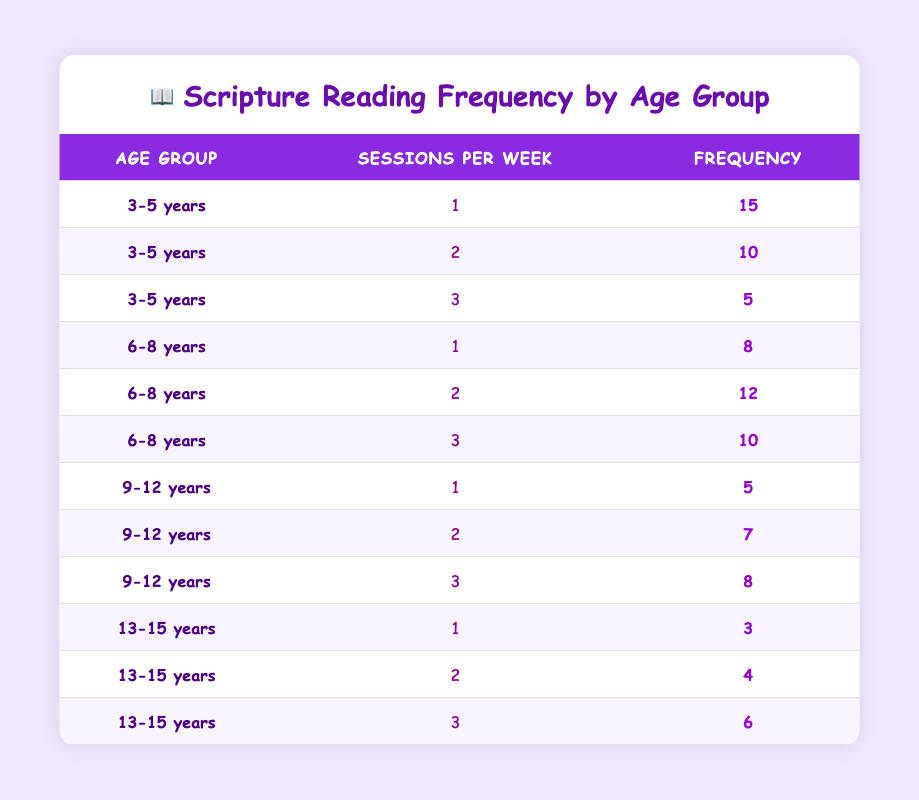What is the frequency of 3 sessions per week for the age group 3-5 years? In the table, under the age group 3-5 years, the frequency for 3 sessions per week is explicitly listed as 5. Therefore, this value can be directly retrieved from the table.
Answer: 5 How many children in the age group 6-8 years participate in one scripture reading session per week? According to the table, for the age group 6-8 years, the frequency for one session per week is recorded as 8. This can be found without further calculations.
Answer: 8 What is the total frequency of children reading scriptures 2 times a week across all age groups? To find this, I look at the table for the frequency of 2 sessions per week for each age group. For 3-5 years, it's 10, for 6-8 years it's 12, for 9-12 years it's 7, and for 13-15 years it's 4. Summing these gives: 10 + 12 + 7 + 4 = 33.
Answer: 33 Is it true that more children in the age group 13-15 years read scriptures 3 times a week compared to those in the age group 9-12 years? Checking the table, the frequency for 3 sessions per week is 6 for the age group 13-15 years and 8 for the age group 9-12 years. Since 6 is less than 8, the statement is false.
Answer: No What is the average number of scripture reading sessions per week for children aged 9-12 years? First, I gather the sessions per week for the age group 9-12 years: 1 session (5 children), 2 sessions (7 children), and 3 sessions (8 children). The total number of sessions is calculated as (1*5 + 2*7 + 3*8) = 5 + 14 + 24 = 43. There are a total of 5 + 7 + 8 = 20 children. Therefore, the average is 43/20 = 2.15.
Answer: 2.15 How many more children read once a week in the age group 3-5 years than in the age group 13-15 years? From the table, 15 children in the age group 3-5 years read once a week, while 3 children in the 13-15 age group do the same. The difference is 15 - 3 = 12.
Answer: 12 What is the total frequency of children reading scriptures 3 times per week? I will check the frequency of 3 sessions per week from all age groups. For 3-5 years it's 5, for 6-8 years it's 10, for 9-12 years it's 8, and for 13-15 years it's 6. Adding these frequencies gives 5 + 10 + 8 + 6 = 29.
Answer: 29 Is there a higher frequency of children reading scriptures 1 time per week than those reading 3 times per week? I will check the table for frequencies. The frequency of 1 time per week for all groups is 15 (3-5 years) + 8 (6-8 years) + 5 (9-12 years) + 3 (13-15 years) = 31. The frequency for 3 times per week is 5 (3-5 years) + 10 (6-8 years) + 8 (9-12 years) + 6 (13-15 years) = 29. Since 31 is greater than 29, the answer is yes.
Answer: Yes 